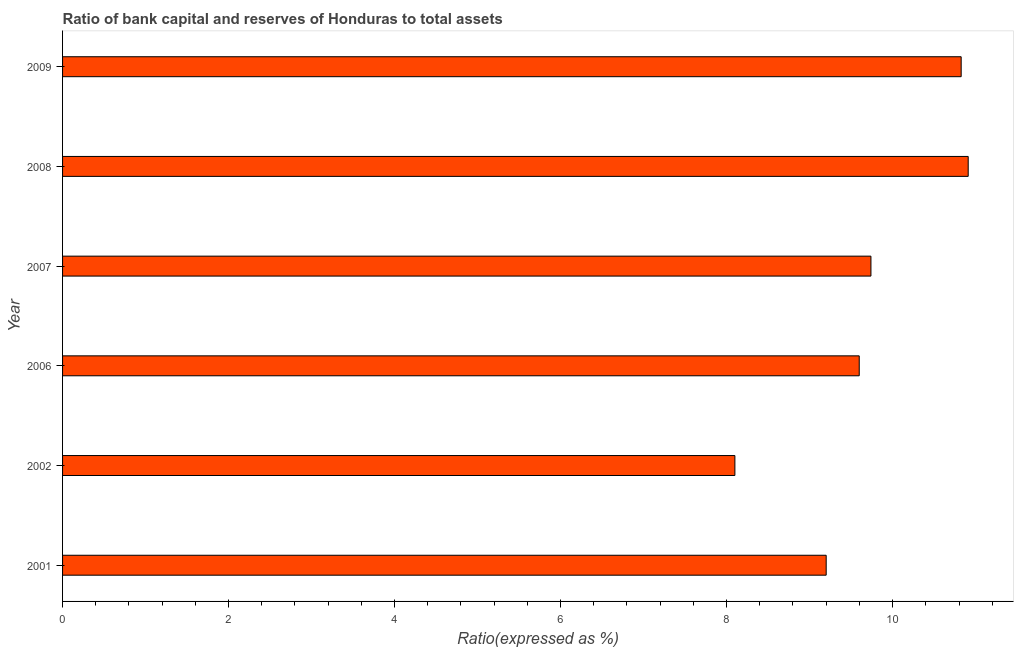Does the graph contain any zero values?
Provide a succinct answer. No. Does the graph contain grids?
Offer a terse response. No. What is the title of the graph?
Your answer should be very brief. Ratio of bank capital and reserves of Honduras to total assets. What is the label or title of the X-axis?
Your answer should be very brief. Ratio(expressed as %). What is the bank capital to assets ratio in 2008?
Provide a succinct answer. 10.91. Across all years, what is the maximum bank capital to assets ratio?
Keep it short and to the point. 10.91. Across all years, what is the minimum bank capital to assets ratio?
Give a very brief answer. 8.1. In which year was the bank capital to assets ratio minimum?
Offer a very short reply. 2002. What is the sum of the bank capital to assets ratio?
Your response must be concise. 58.37. What is the difference between the bank capital to assets ratio in 2001 and 2002?
Your answer should be very brief. 1.1. What is the average bank capital to assets ratio per year?
Ensure brevity in your answer.  9.73. What is the median bank capital to assets ratio?
Keep it short and to the point. 9.67. What is the difference between the highest and the second highest bank capital to assets ratio?
Keep it short and to the point. 0.09. Is the sum of the bank capital to assets ratio in 2001 and 2002 greater than the maximum bank capital to assets ratio across all years?
Provide a short and direct response. Yes. What is the difference between the highest and the lowest bank capital to assets ratio?
Provide a succinct answer. 2.81. In how many years, is the bank capital to assets ratio greater than the average bank capital to assets ratio taken over all years?
Keep it short and to the point. 3. How many bars are there?
Keep it short and to the point. 6. Are all the bars in the graph horizontal?
Offer a very short reply. Yes. How many years are there in the graph?
Provide a succinct answer. 6. What is the difference between two consecutive major ticks on the X-axis?
Make the answer very short. 2. What is the Ratio(expressed as %) in 2006?
Your response must be concise. 9.6. What is the Ratio(expressed as %) in 2007?
Keep it short and to the point. 9.74. What is the Ratio(expressed as %) in 2008?
Your answer should be very brief. 10.91. What is the Ratio(expressed as %) in 2009?
Offer a terse response. 10.83. What is the difference between the Ratio(expressed as %) in 2001 and 2006?
Provide a succinct answer. -0.4. What is the difference between the Ratio(expressed as %) in 2001 and 2007?
Give a very brief answer. -0.54. What is the difference between the Ratio(expressed as %) in 2001 and 2008?
Make the answer very short. -1.71. What is the difference between the Ratio(expressed as %) in 2001 and 2009?
Provide a succinct answer. -1.63. What is the difference between the Ratio(expressed as %) in 2002 and 2006?
Your answer should be compact. -1.5. What is the difference between the Ratio(expressed as %) in 2002 and 2007?
Give a very brief answer. -1.64. What is the difference between the Ratio(expressed as %) in 2002 and 2008?
Your response must be concise. -2.81. What is the difference between the Ratio(expressed as %) in 2002 and 2009?
Your response must be concise. -2.73. What is the difference between the Ratio(expressed as %) in 2006 and 2007?
Provide a short and direct response. -0.14. What is the difference between the Ratio(expressed as %) in 2006 and 2008?
Your response must be concise. -1.31. What is the difference between the Ratio(expressed as %) in 2006 and 2009?
Make the answer very short. -1.23. What is the difference between the Ratio(expressed as %) in 2007 and 2008?
Ensure brevity in your answer.  -1.17. What is the difference between the Ratio(expressed as %) in 2007 and 2009?
Ensure brevity in your answer.  -1.09. What is the difference between the Ratio(expressed as %) in 2008 and 2009?
Your response must be concise. 0.08. What is the ratio of the Ratio(expressed as %) in 2001 to that in 2002?
Provide a short and direct response. 1.14. What is the ratio of the Ratio(expressed as %) in 2001 to that in 2006?
Provide a short and direct response. 0.96. What is the ratio of the Ratio(expressed as %) in 2001 to that in 2007?
Keep it short and to the point. 0.94. What is the ratio of the Ratio(expressed as %) in 2001 to that in 2008?
Provide a short and direct response. 0.84. What is the ratio of the Ratio(expressed as %) in 2002 to that in 2006?
Give a very brief answer. 0.84. What is the ratio of the Ratio(expressed as %) in 2002 to that in 2007?
Provide a short and direct response. 0.83. What is the ratio of the Ratio(expressed as %) in 2002 to that in 2008?
Your answer should be compact. 0.74. What is the ratio of the Ratio(expressed as %) in 2002 to that in 2009?
Make the answer very short. 0.75. What is the ratio of the Ratio(expressed as %) in 2006 to that in 2007?
Your answer should be very brief. 0.99. What is the ratio of the Ratio(expressed as %) in 2006 to that in 2009?
Give a very brief answer. 0.89. What is the ratio of the Ratio(expressed as %) in 2007 to that in 2008?
Your answer should be very brief. 0.89. What is the ratio of the Ratio(expressed as %) in 2007 to that in 2009?
Your answer should be very brief. 0.9. What is the ratio of the Ratio(expressed as %) in 2008 to that in 2009?
Your answer should be very brief. 1.01. 